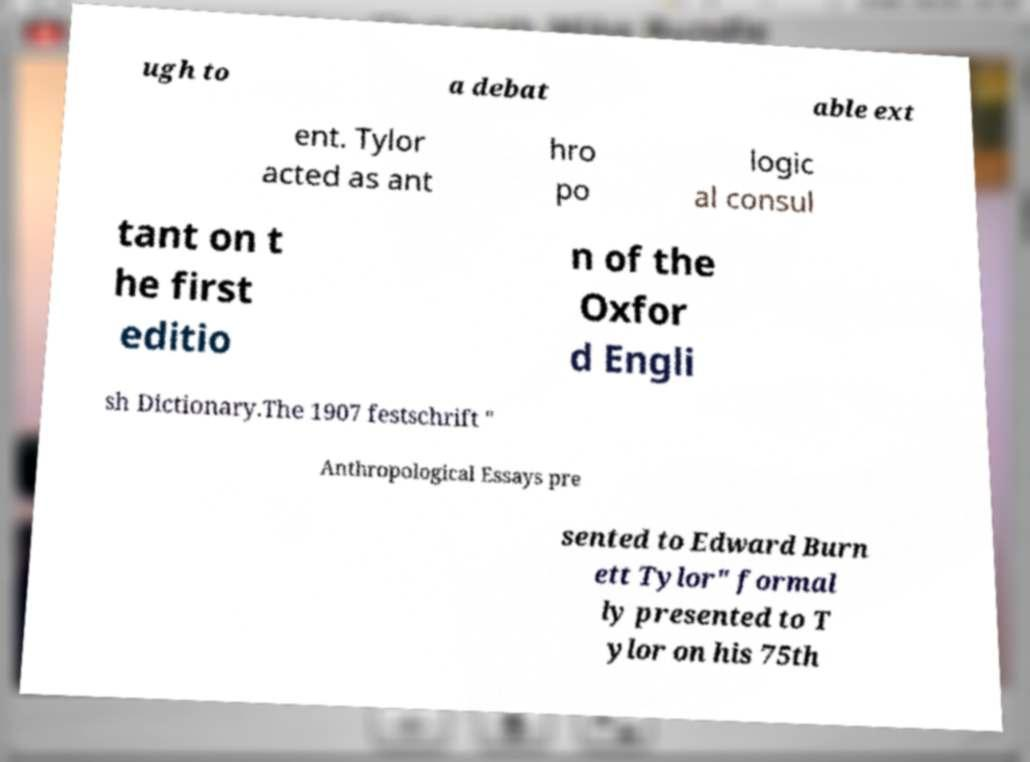Could you assist in decoding the text presented in this image and type it out clearly? ugh to a debat able ext ent. Tylor acted as ant hro po logic al consul tant on t he first editio n of the Oxfor d Engli sh Dictionary.The 1907 festschrift " Anthropological Essays pre sented to Edward Burn ett Tylor" formal ly presented to T ylor on his 75th 